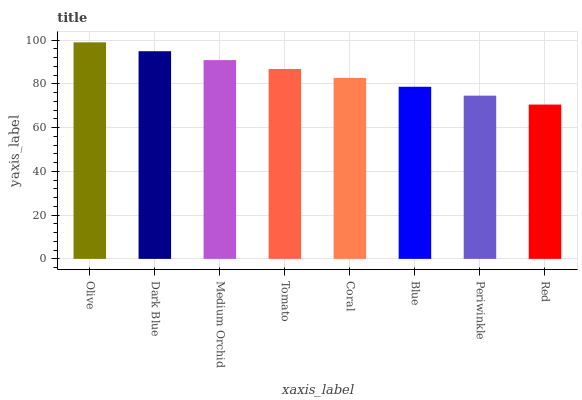Is Red the minimum?
Answer yes or no. Yes. Is Olive the maximum?
Answer yes or no. Yes. Is Dark Blue the minimum?
Answer yes or no. No. Is Dark Blue the maximum?
Answer yes or no. No. Is Olive greater than Dark Blue?
Answer yes or no. Yes. Is Dark Blue less than Olive?
Answer yes or no. Yes. Is Dark Blue greater than Olive?
Answer yes or no. No. Is Olive less than Dark Blue?
Answer yes or no. No. Is Tomato the high median?
Answer yes or no. Yes. Is Coral the low median?
Answer yes or no. Yes. Is Periwinkle the high median?
Answer yes or no. No. Is Periwinkle the low median?
Answer yes or no. No. 